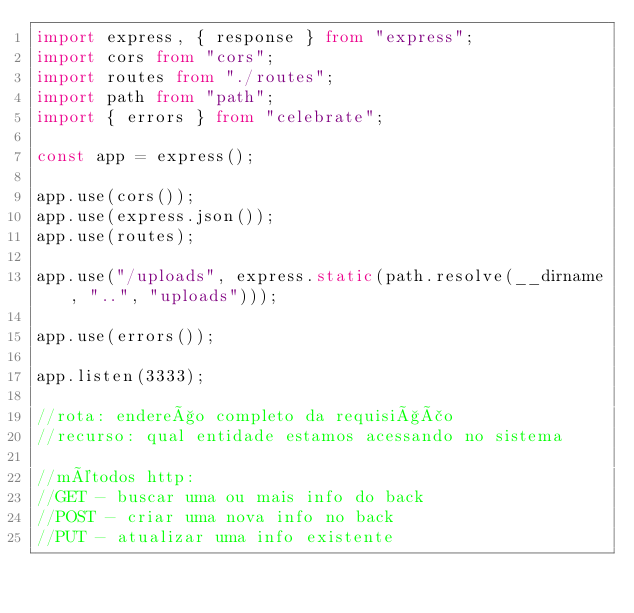<code> <loc_0><loc_0><loc_500><loc_500><_TypeScript_>import express, { response } from "express";
import cors from "cors";
import routes from "./routes";
import path from "path";
import { errors } from "celebrate";

const app = express();

app.use(cors());
app.use(express.json());
app.use(routes);

app.use("/uploads", express.static(path.resolve(__dirname, "..", "uploads")));

app.use(errors());

app.listen(3333);

//rota: endereço completo da requisição
//recurso: qual entidade estamos acessando no sistema

//métodos http:
//GET - buscar uma ou mais info do back
//POST - criar uma nova info no back
//PUT - atualizar uma info existente</code> 